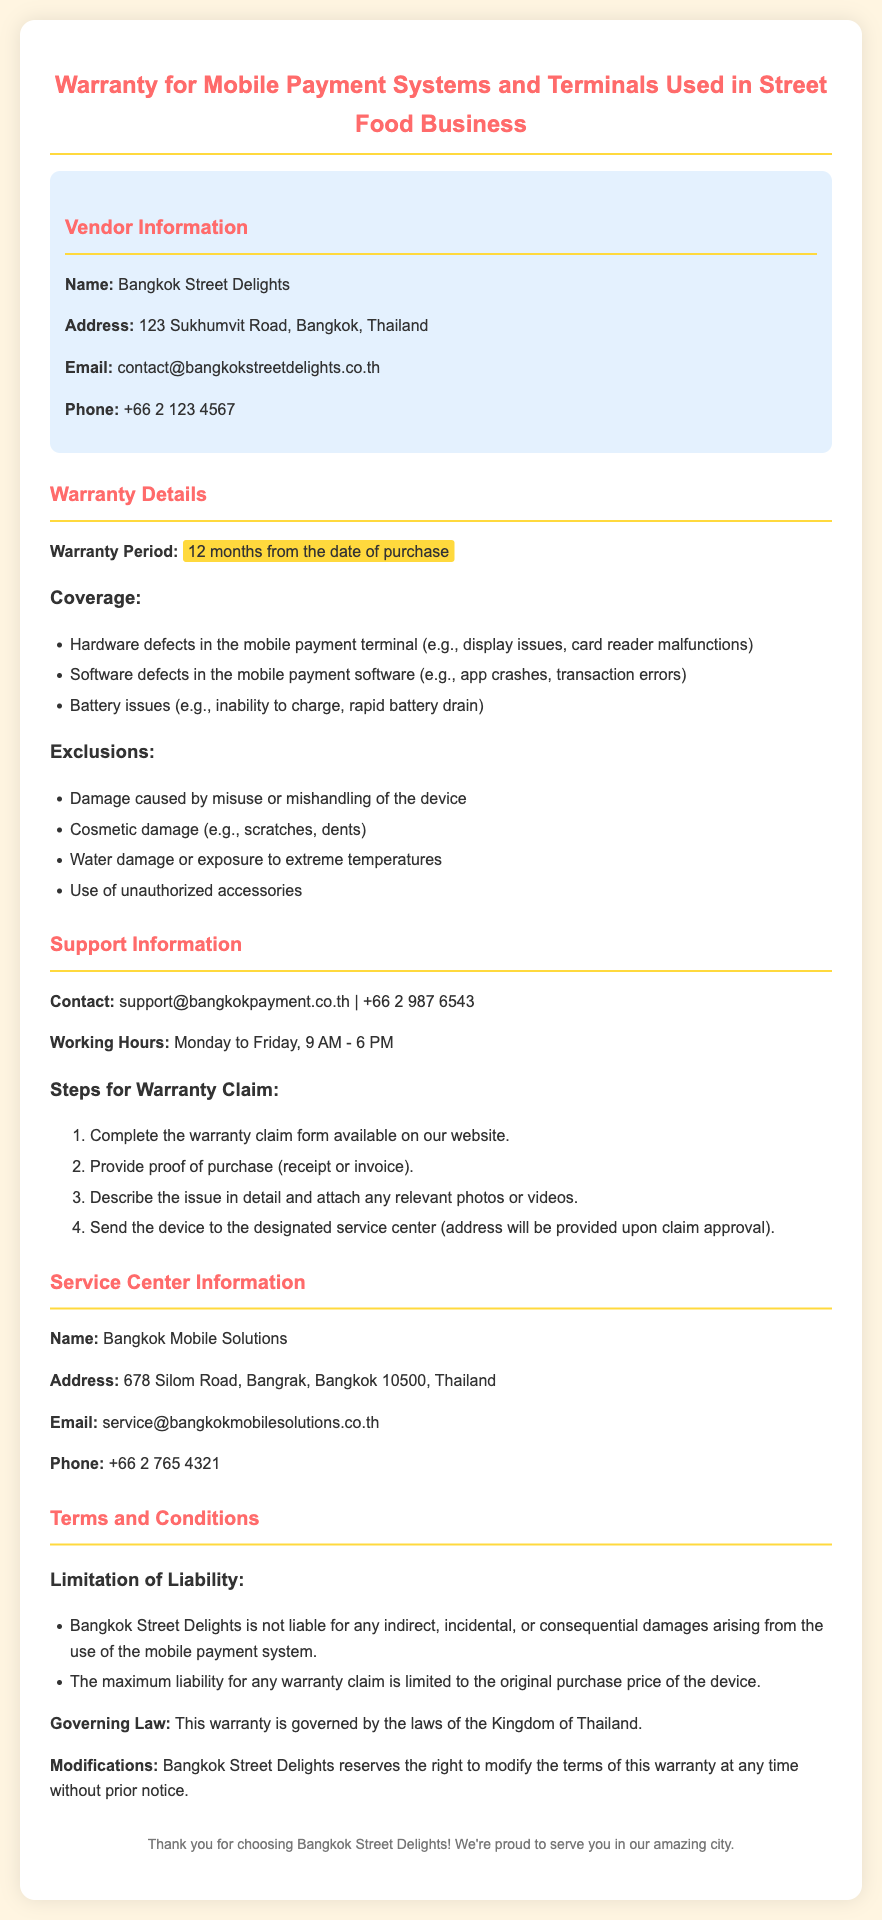What is the name of the vendor? The document specifies the name of the vendor as "Bangkok Street Delights."
Answer: Bangkok Street Delights What is the warranty period? The document states that the warranty period is 12 months from the date of purchase.
Answer: 12 months What types of issues are covered under the warranty? The document lists hardware defects, software defects, and battery issues as covered problems.
Answer: Hardware defects, software defects, battery issues What is excluded from the warranty? The document enumerates damage caused by misuse, cosmetic damage, water damage, and unauthorized accessories as exclusions.
Answer: Misuse, cosmetic damage, water damage, unauthorized accessories What steps are needed for a warranty claim? The document outlines a sequence of steps: completing a form, providing proof of purchase, describing the issue, and sending the device to the service center.
Answer: Complete claim form, provide proof of purchase, describe issue, send device What is the maximum liability for any warranty claim? The document specifies that the maximum liability is limited to the original purchase price of the device.
Answer: Original purchase price What is the address of the service center? The document provides the address of the service center as 678 Silom Road, Bangrak, Bangkok 10500, Thailand.
Answer: 678 Silom Road, Bangrak, Bangkok 10500, Thailand What is the email contact for support? The document lists the support email as support@bangkokpayment.co.th.
Answer: support@bangkokpayment.co.th Under which law is this warranty governed? The document states that the warranty is governed by the laws of the Kingdom of Thailand.
Answer: Kingdom of Thailand 